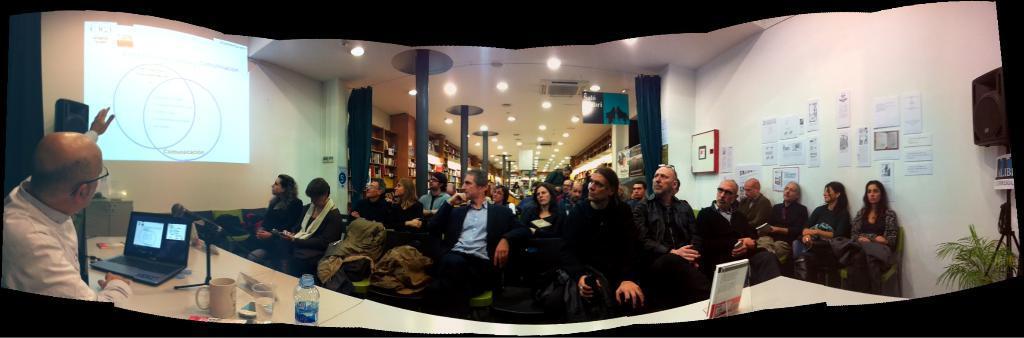In one or two sentences, can you explain what this image depicts? This is an edited image with the borders. On the left we can see the tables on the top of which water bottle, glass, cup, laptop, microphone and some other items are placed and we can see the jackets are placed on the top of the chairs. In the background we can see the wall, posters attached to the wall and we can see the group of persons sitting on the chairs and at the top there is a roof and we can see the ceiling lights, pillars, curtains, projector screen, speaker, house plant and many other objects. 